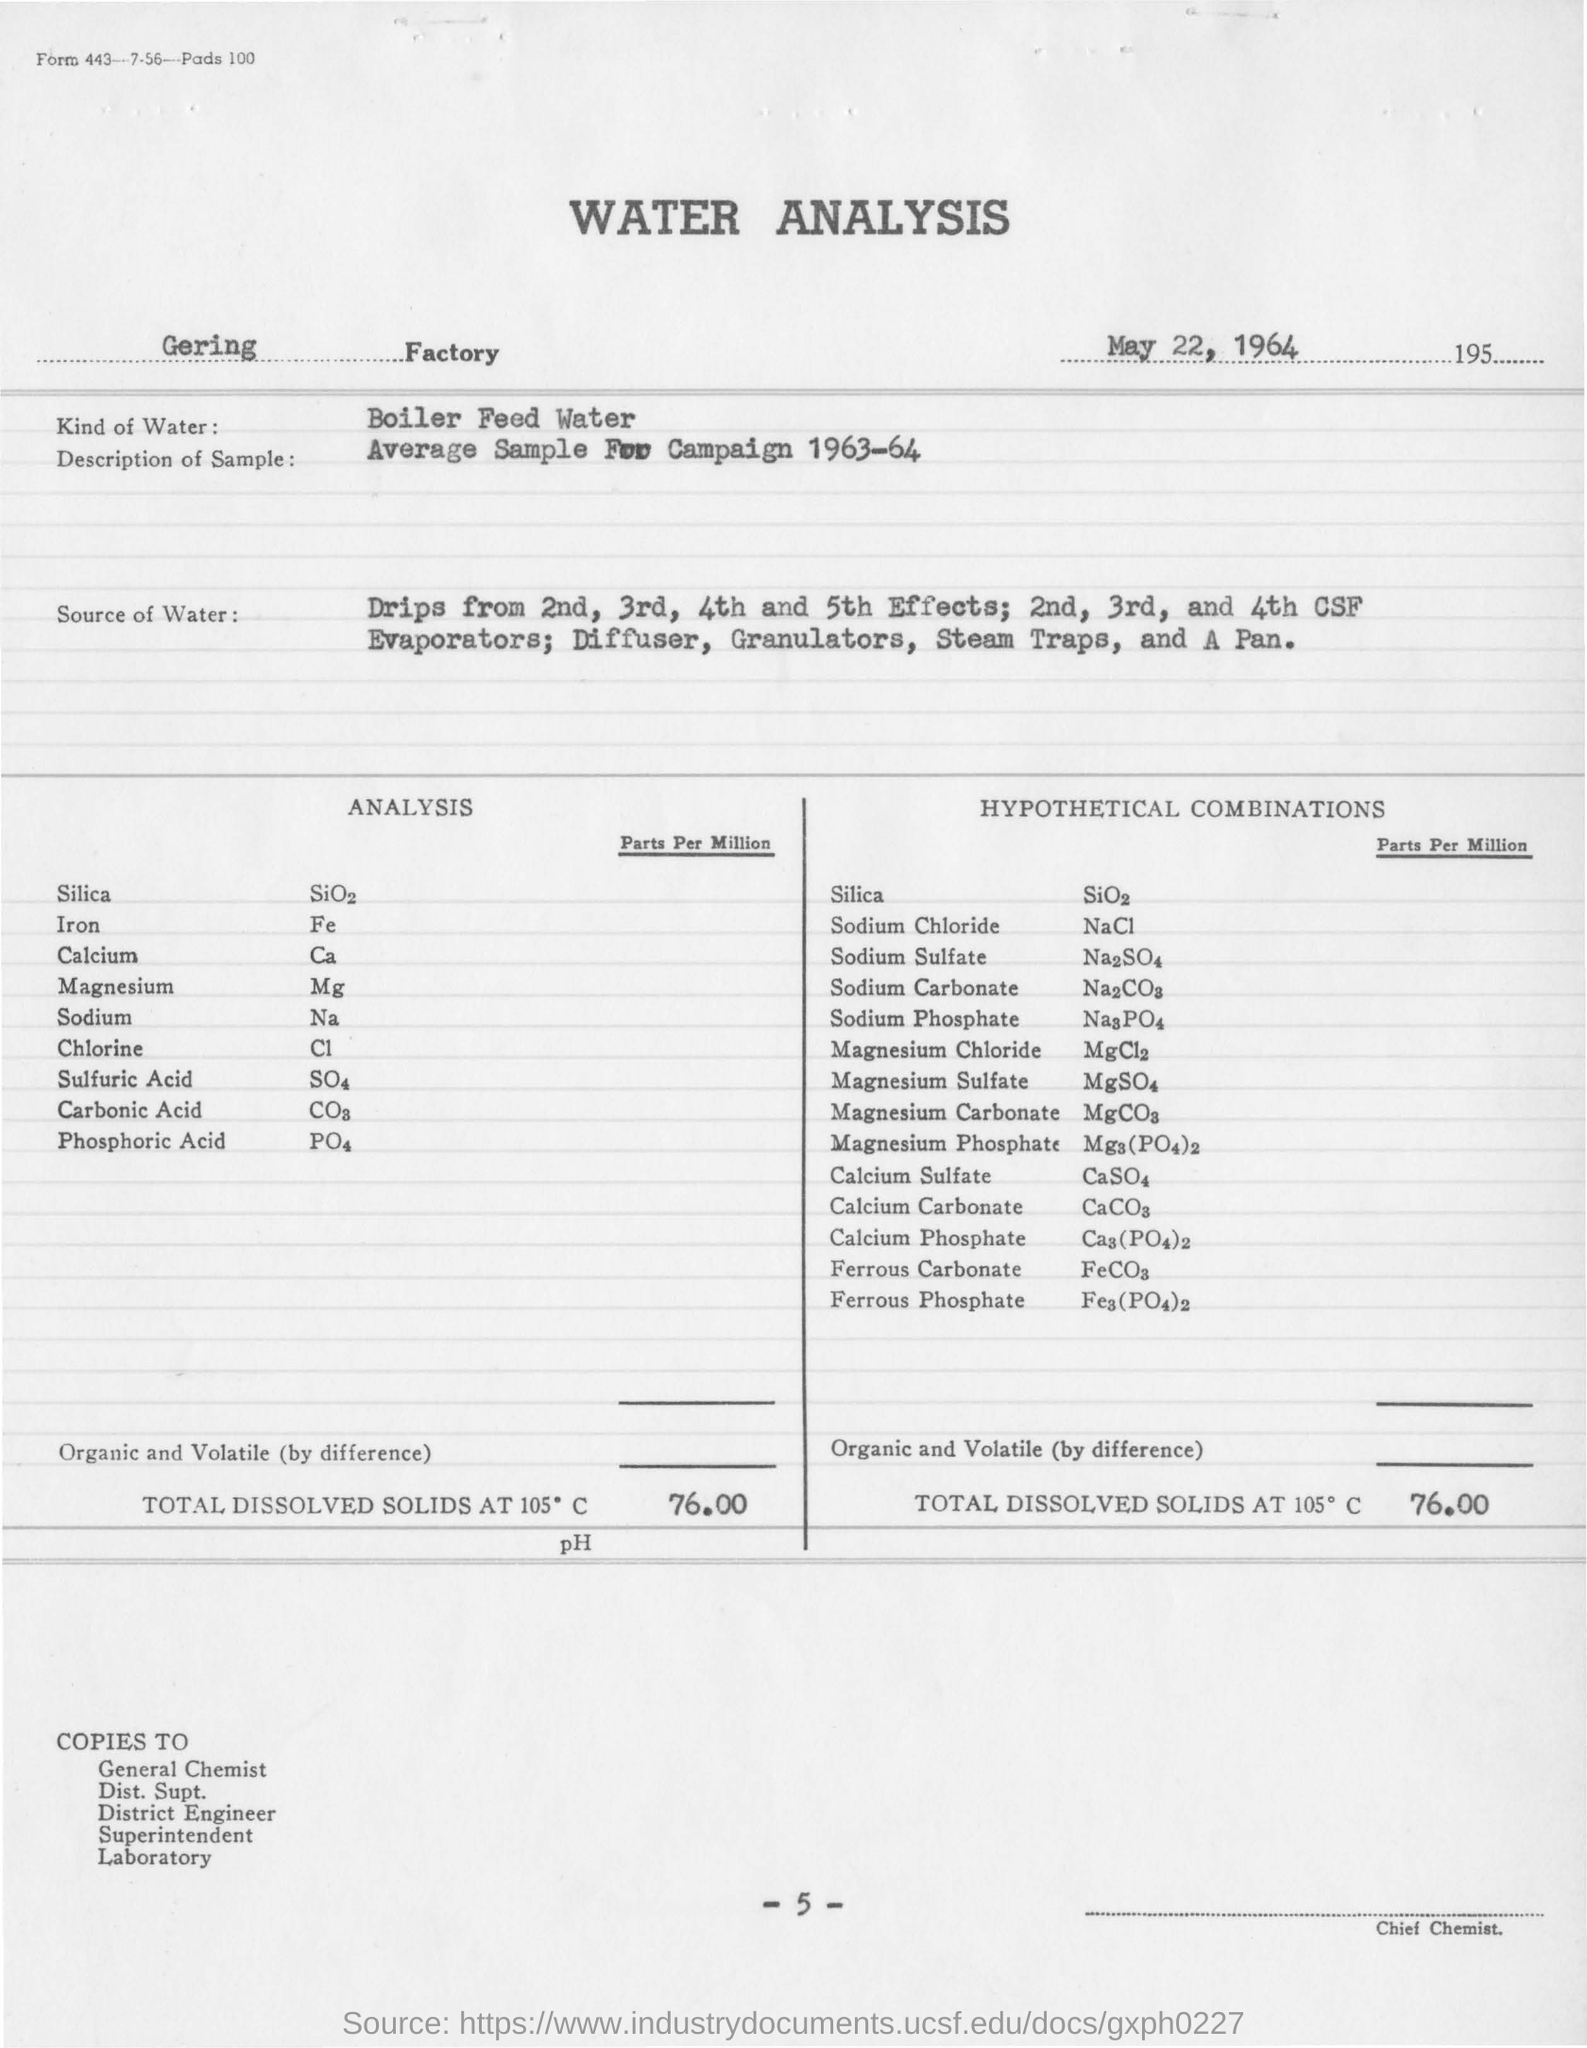What is the name of the factory ?
Offer a very short reply. Gering factory. What is the kind of water used in analysis ?
Offer a very short reply. Boiler Feed Water. What is the amount of total dissolved solids at 105 degrees c ?
Your response must be concise. 76.00. What kind of water is used for the analysis?
Your answer should be compact. Bioler Feed Water. 